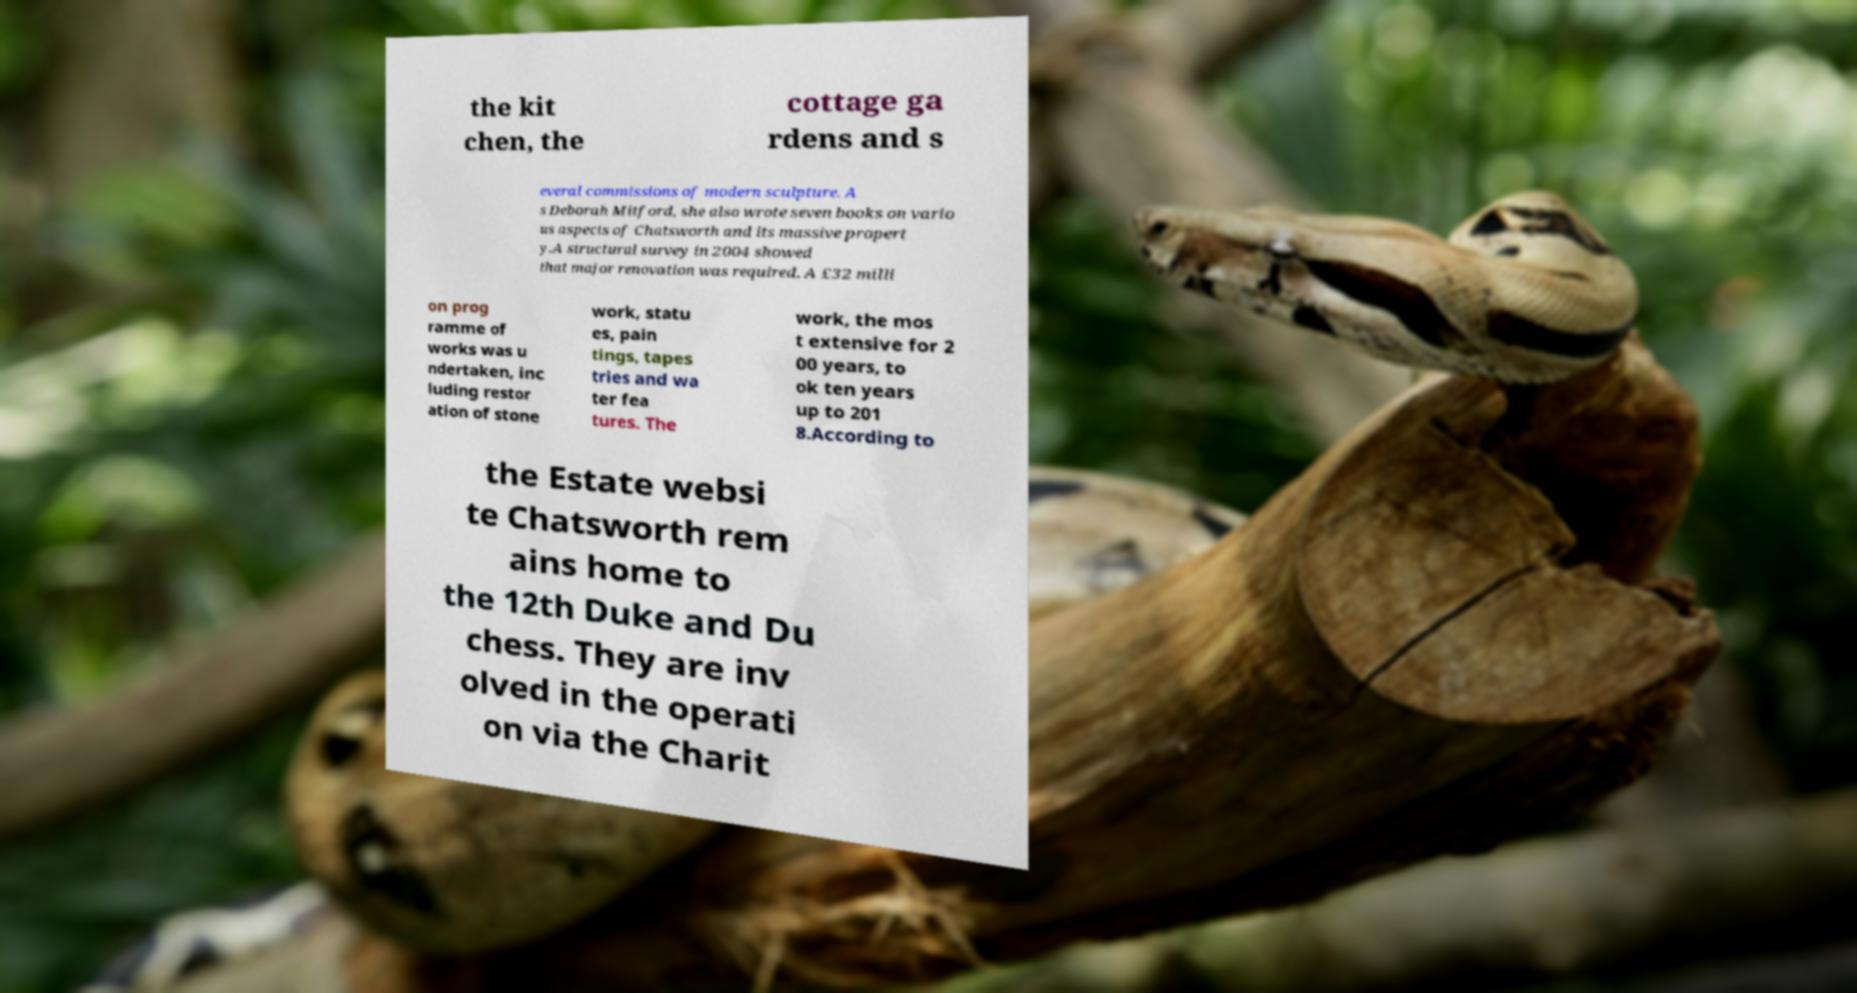Can you read and provide the text displayed in the image?This photo seems to have some interesting text. Can you extract and type it out for me? the kit chen, the cottage ga rdens and s everal commissions of modern sculpture. A s Deborah Mitford, she also wrote seven books on vario us aspects of Chatsworth and its massive propert y.A structural survey in 2004 showed that major renovation was required. A £32 milli on prog ramme of works was u ndertaken, inc luding restor ation of stone work, statu es, pain tings, tapes tries and wa ter fea tures. The work, the mos t extensive for 2 00 years, to ok ten years up to 201 8.According to the Estate websi te Chatsworth rem ains home to the 12th Duke and Du chess. They are inv olved in the operati on via the Charit 